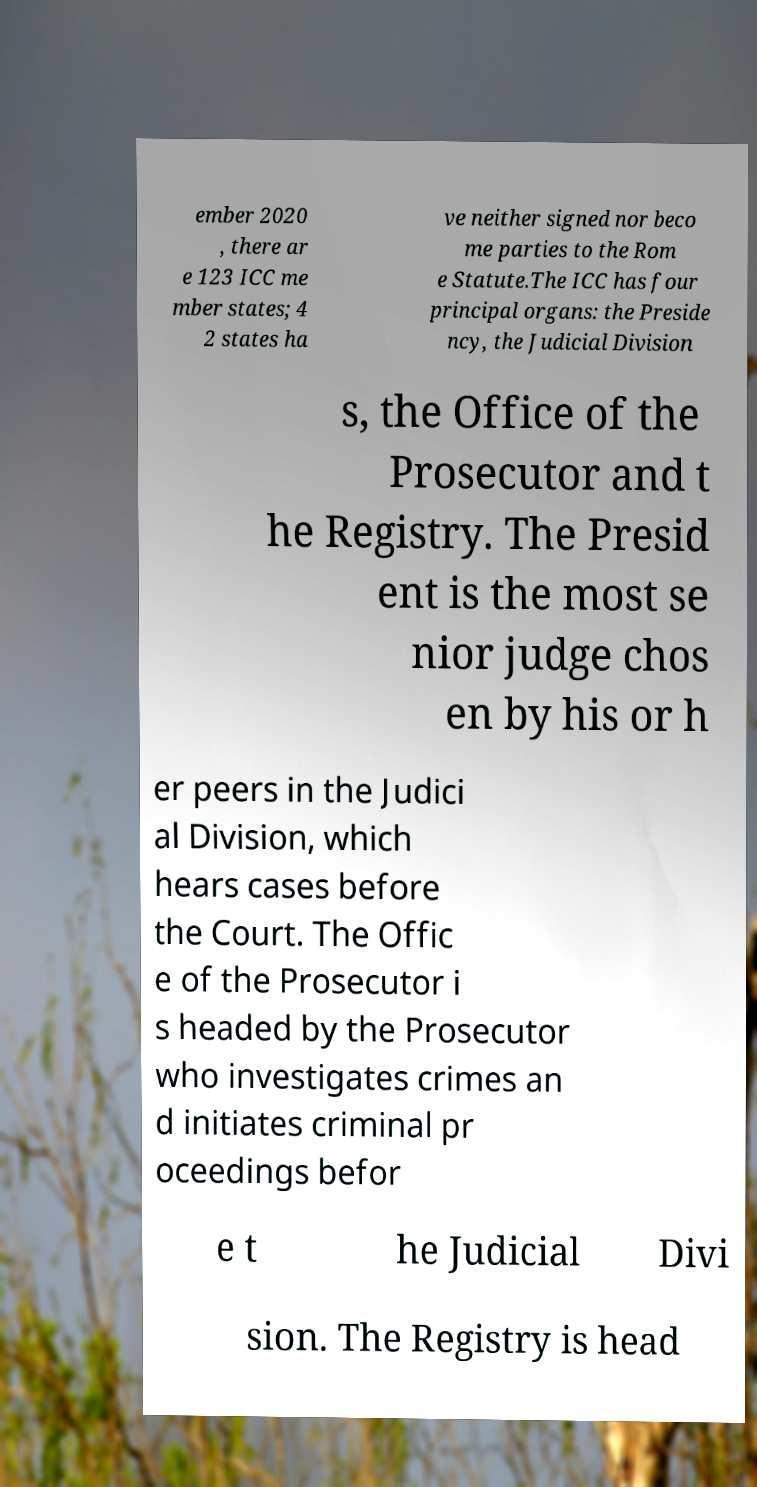There's text embedded in this image that I need extracted. Can you transcribe it verbatim? ember 2020 , there ar e 123 ICC me mber states; 4 2 states ha ve neither signed nor beco me parties to the Rom e Statute.The ICC has four principal organs: the Preside ncy, the Judicial Division s, the Office of the Prosecutor and t he Registry. The Presid ent is the most se nior judge chos en by his or h er peers in the Judici al Division, which hears cases before the Court. The Offic e of the Prosecutor i s headed by the Prosecutor who investigates crimes an d initiates criminal pr oceedings befor e t he Judicial Divi sion. The Registry is head 